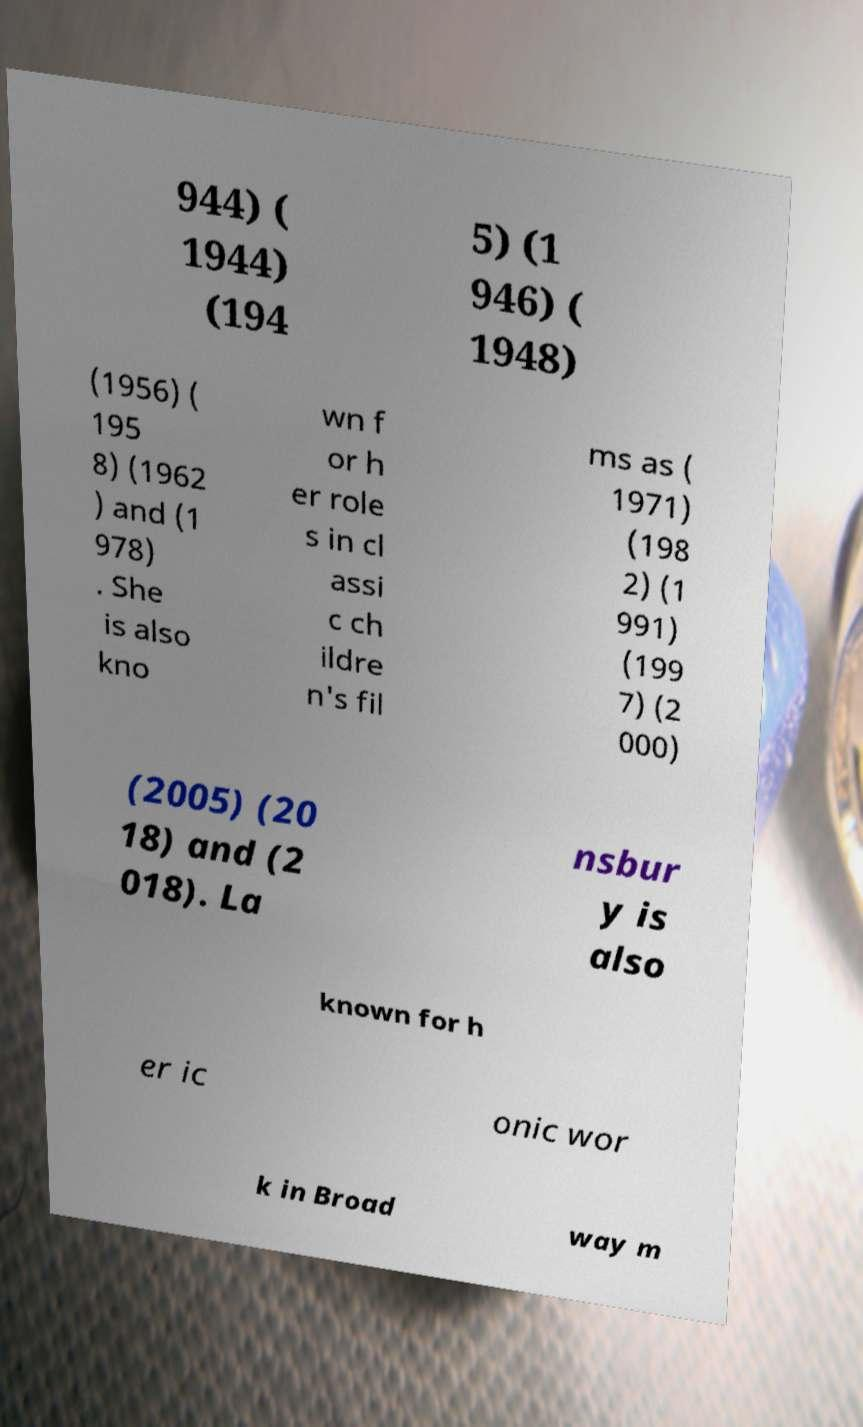Please read and relay the text visible in this image. What does it say? 944) ( 1944) (194 5) (1 946) ( 1948) (1956) ( 195 8) (1962 ) and (1 978) . She is also kno wn f or h er role s in cl assi c ch ildre n's fil ms as ( 1971) (198 2) (1 991) (199 7) (2 000) (2005) (20 18) and (2 018). La nsbur y is also known for h er ic onic wor k in Broad way m 